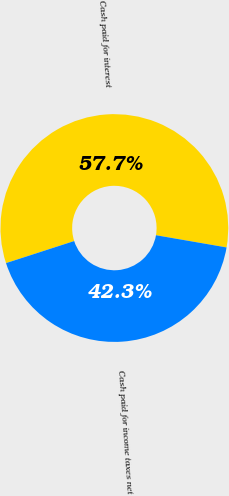Convert chart to OTSL. <chart><loc_0><loc_0><loc_500><loc_500><pie_chart><fcel>Cash paid for interest<fcel>Cash paid for income taxes net<nl><fcel>57.71%<fcel>42.29%<nl></chart> 